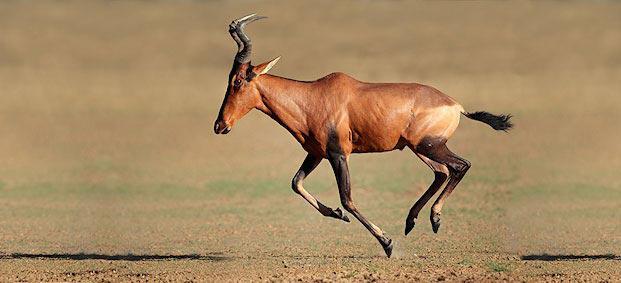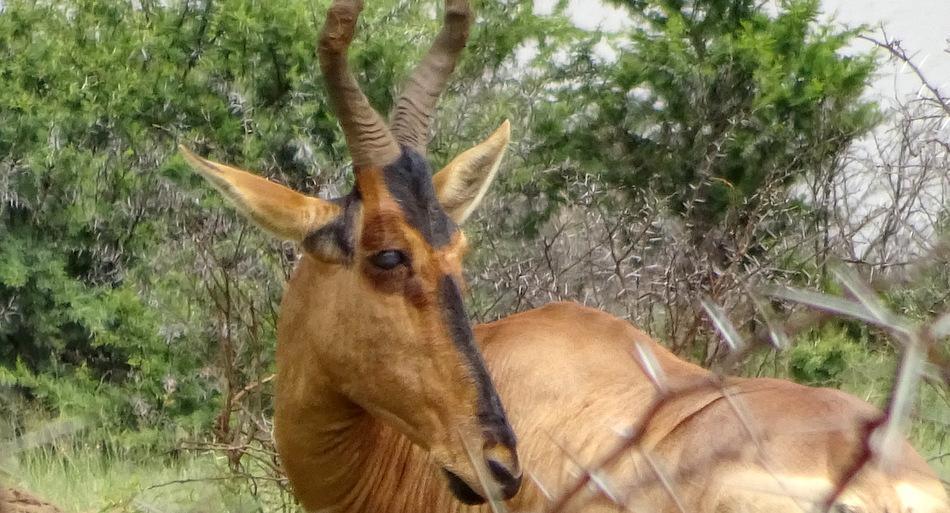The first image is the image on the left, the second image is the image on the right. Evaluate the accuracy of this statement regarding the images: "Two brown horned animals positioned sideways toward the same direction are alone in a wilderness area, at least one of them showing its tail.". Is it true? Answer yes or no. No. The first image is the image on the left, the second image is the image on the right. Given the left and right images, does the statement "Two antelopes are facing right." hold true? Answer yes or no. No. 